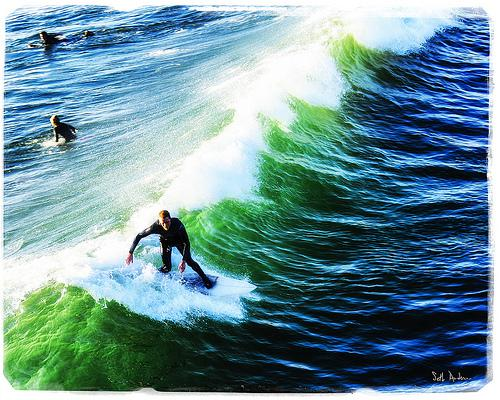Question: what are the people doing?
Choices:
A. Skiing.
B. Bungee jumping.
C. Skateboarding.
D. Surfing.
Answer with the letter. Answer: D Question: where was this photographed?
Choices:
A. The sunset.
B. The ocean.
C. A tree.
D. A mountain.
Answer with the letter. Answer: B Question: what are the people standing on?
Choices:
A. A motorboat.
B. Surfboards.
C. A ski jet.
D. A canoe.
Answer with the letter. Answer: B 